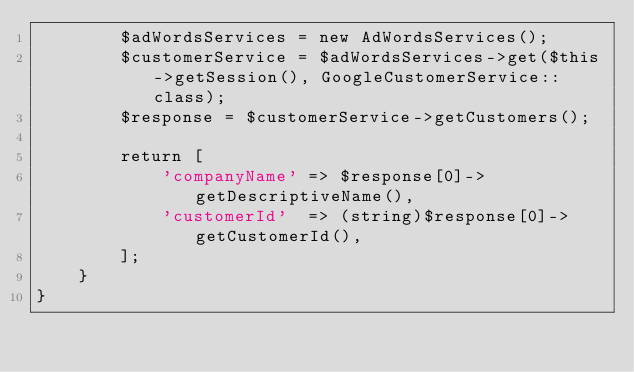<code> <loc_0><loc_0><loc_500><loc_500><_PHP_>		$adWordsServices = new AdWordsServices();
		$customerService = $adWordsServices->get($this->getSession(), GoogleCustomerService::class);
        $response = $customerService->getCustomers();

        return [
            'companyName' => $response[0]->getDescriptiveName(),
            'customerId'  => (string)$response[0]->getCustomerId(),
        ];
	}
}
</code> 